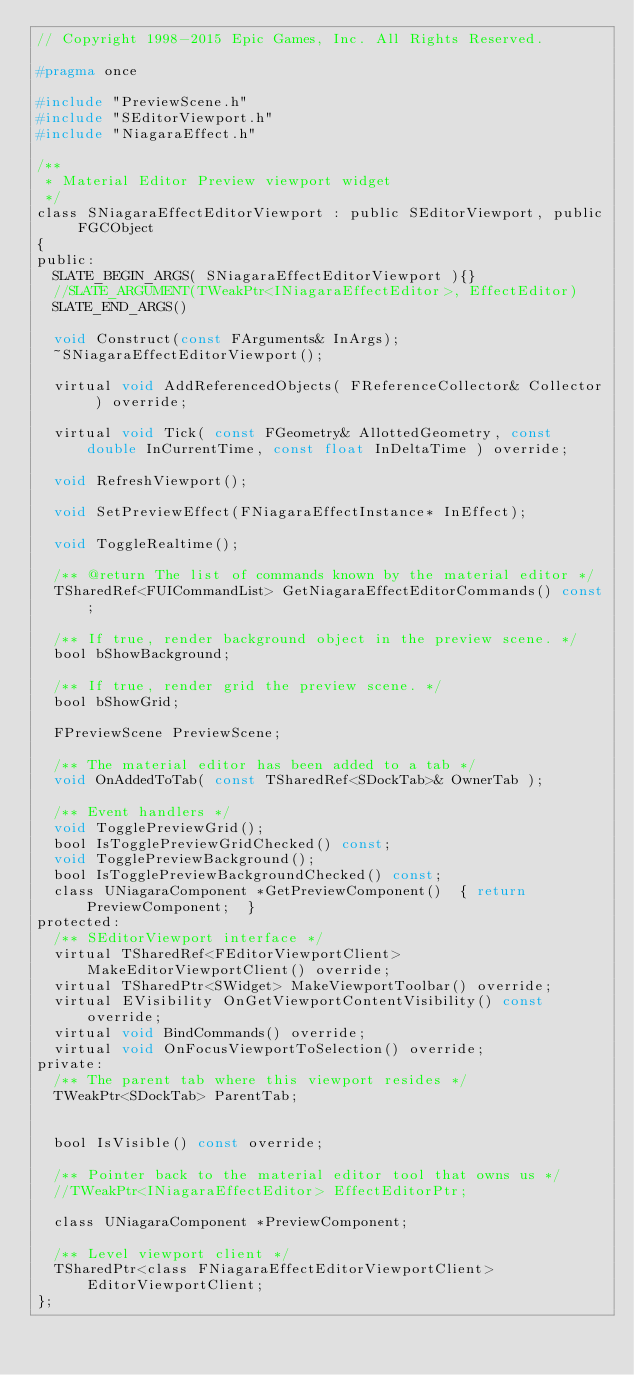Convert code to text. <code><loc_0><loc_0><loc_500><loc_500><_C_>// Copyright 1998-2015 Epic Games, Inc. All Rights Reserved.

#pragma once

#include "PreviewScene.h"
#include "SEditorViewport.h"
#include "NiagaraEffect.h"

/**
 * Material Editor Preview viewport widget
 */
class SNiagaraEffectEditorViewport : public SEditorViewport, public FGCObject
{
public:
	SLATE_BEGIN_ARGS( SNiagaraEffectEditorViewport ){}
	//SLATE_ARGUMENT(TWeakPtr<INiagaraEffectEditor>, EffectEditor)
	SLATE_END_ARGS()
	
	void Construct(const FArguments& InArgs);
	~SNiagaraEffectEditorViewport();
	
	virtual void AddReferencedObjects( FReferenceCollector& Collector ) override;
	
	virtual void Tick( const FGeometry& AllottedGeometry, const double InCurrentTime, const float InDeltaTime ) override;

	void RefreshViewport();
	
	void SetPreviewEffect(FNiagaraEffectInstance* InEffect);
	
	void ToggleRealtime();
	
	/** @return The list of commands known by the material editor */
	TSharedRef<FUICommandList> GetNiagaraEffectEditorCommands() const;
	
	/** If true, render background object in the preview scene. */
	bool bShowBackground;
	
	/** If true, render grid the preview scene. */
	bool bShowGrid;
	
	FPreviewScene PreviewScene;
	
	/** The material editor has been added to a tab */
	void OnAddedToTab( const TSharedRef<SDockTab>& OwnerTab );
	
	/** Event handlers */
	void TogglePreviewGrid();
	bool IsTogglePreviewGridChecked() const;
	void TogglePreviewBackground();
	bool IsTogglePreviewBackgroundChecked() const;
	class UNiagaraComponent *GetPreviewComponent()	{ return PreviewComponent;  }
protected:
	/** SEditorViewport interface */
	virtual TSharedRef<FEditorViewportClient> MakeEditorViewportClient() override;
	virtual TSharedPtr<SWidget> MakeViewportToolbar() override;
	virtual EVisibility OnGetViewportContentVisibility() const override;
	virtual void BindCommands() override;
	virtual void OnFocusViewportToSelection() override;
private:
	/** The parent tab where this viewport resides */
	TWeakPtr<SDockTab> ParentTab;
	
	
	bool IsVisible() const override;
	
	/** Pointer back to the material editor tool that owns us */
	//TWeakPtr<INiagaraEffectEditor> EffectEditorPtr;
	
	class UNiagaraComponent *PreviewComponent;
	
	/** Level viewport client */
	TSharedPtr<class FNiagaraEffectEditorViewportClient> EditorViewportClient;
};
</code> 